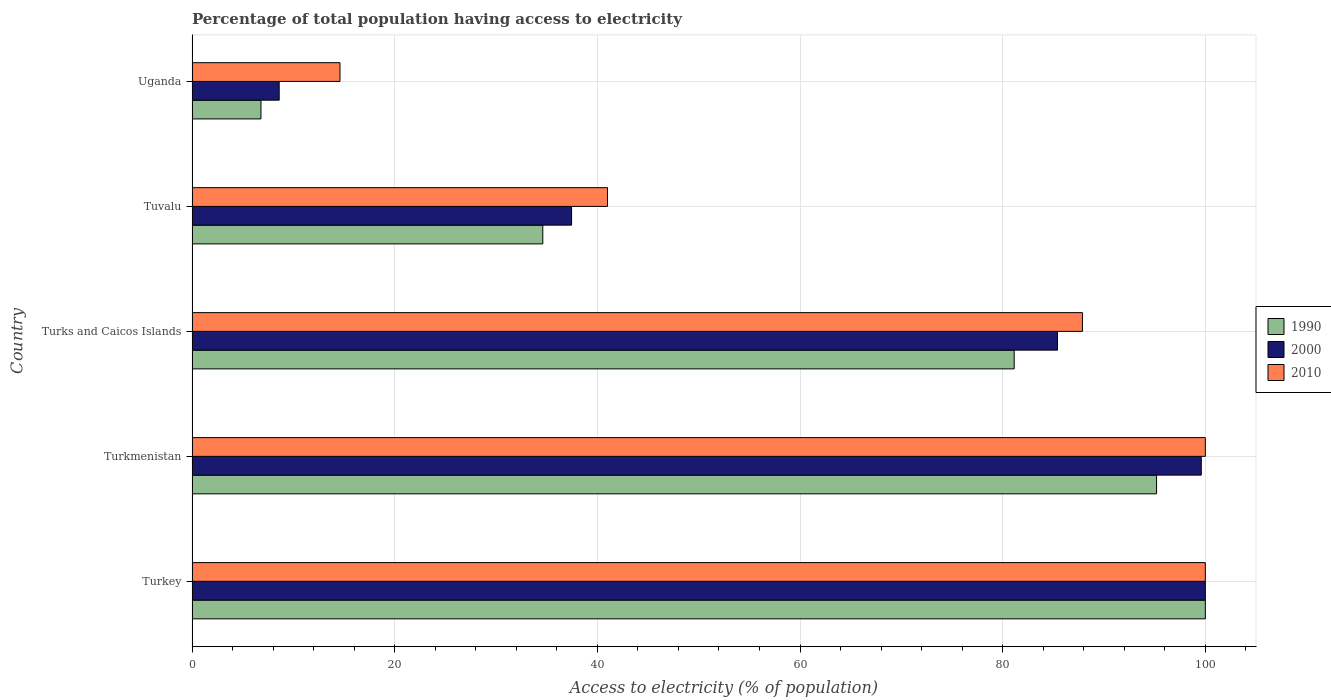How many groups of bars are there?
Give a very brief answer. 5. Are the number of bars per tick equal to the number of legend labels?
Your answer should be very brief. Yes. What is the label of the 3rd group of bars from the top?
Offer a very short reply. Turks and Caicos Islands. What is the percentage of population that have access to electricity in 2010 in Turkmenistan?
Provide a succinct answer. 100. Across all countries, what is the minimum percentage of population that have access to electricity in 2000?
Make the answer very short. 8.6. In which country was the percentage of population that have access to electricity in 1990 maximum?
Keep it short and to the point. Turkey. In which country was the percentage of population that have access to electricity in 2010 minimum?
Offer a terse response. Uganda. What is the total percentage of population that have access to electricity in 2000 in the graph?
Give a very brief answer. 331.07. What is the difference between the percentage of population that have access to electricity in 1990 in Turks and Caicos Islands and that in Tuvalu?
Ensure brevity in your answer.  46.52. What is the difference between the percentage of population that have access to electricity in 2010 in Uganda and the percentage of population that have access to electricity in 2000 in Tuvalu?
Provide a succinct answer. -22.86. What is the average percentage of population that have access to electricity in 2010 per country?
Provide a short and direct response. 68.69. What is the difference between the percentage of population that have access to electricity in 2010 and percentage of population that have access to electricity in 2000 in Uganda?
Your answer should be compact. 6. What is the ratio of the percentage of population that have access to electricity in 2000 in Turks and Caicos Islands to that in Uganda?
Your answer should be compact. 9.93. Is the percentage of population that have access to electricity in 1990 in Turkey less than that in Turks and Caicos Islands?
Provide a succinct answer. No. Is the difference between the percentage of population that have access to electricity in 2010 in Turks and Caicos Islands and Uganda greater than the difference between the percentage of population that have access to electricity in 2000 in Turks and Caicos Islands and Uganda?
Give a very brief answer. No. What is the difference between the highest and the second highest percentage of population that have access to electricity in 1990?
Ensure brevity in your answer.  4.81. What is the difference between the highest and the lowest percentage of population that have access to electricity in 2010?
Make the answer very short. 85.4. Is the sum of the percentage of population that have access to electricity in 2000 in Turkmenistan and Uganda greater than the maximum percentage of population that have access to electricity in 1990 across all countries?
Give a very brief answer. Yes. How many countries are there in the graph?
Make the answer very short. 5. What is the difference between two consecutive major ticks on the X-axis?
Offer a very short reply. 20. Are the values on the major ticks of X-axis written in scientific E-notation?
Give a very brief answer. No. Does the graph contain grids?
Your answer should be very brief. Yes. What is the title of the graph?
Keep it short and to the point. Percentage of total population having access to electricity. Does "2002" appear as one of the legend labels in the graph?
Provide a succinct answer. No. What is the label or title of the X-axis?
Offer a very short reply. Access to electricity (% of population). What is the label or title of the Y-axis?
Your answer should be very brief. Country. What is the Access to electricity (% of population) in 1990 in Turkmenistan?
Offer a very short reply. 95.19. What is the Access to electricity (% of population) of 2000 in Turkmenistan?
Your answer should be very brief. 99.6. What is the Access to electricity (% of population) of 2010 in Turkmenistan?
Your answer should be very brief. 100. What is the Access to electricity (% of population) of 1990 in Turks and Caicos Islands?
Your response must be concise. 81.14. What is the Access to electricity (% of population) of 2000 in Turks and Caicos Islands?
Make the answer very short. 85.41. What is the Access to electricity (% of population) of 2010 in Turks and Caicos Islands?
Your response must be concise. 87.87. What is the Access to electricity (% of population) of 1990 in Tuvalu?
Make the answer very short. 34.62. What is the Access to electricity (% of population) of 2000 in Tuvalu?
Provide a succinct answer. 37.46. What is the Access to electricity (% of population) of 1990 in Uganda?
Offer a very short reply. 6.8. What is the Access to electricity (% of population) of 2000 in Uganda?
Your response must be concise. 8.6. What is the Access to electricity (% of population) of 2010 in Uganda?
Offer a very short reply. 14.6. Across all countries, what is the maximum Access to electricity (% of population) of 1990?
Give a very brief answer. 100. Across all countries, what is the maximum Access to electricity (% of population) in 2000?
Your answer should be very brief. 100. Across all countries, what is the minimum Access to electricity (% of population) in 2010?
Provide a short and direct response. 14.6. What is the total Access to electricity (% of population) of 1990 in the graph?
Keep it short and to the point. 317.74. What is the total Access to electricity (% of population) in 2000 in the graph?
Ensure brevity in your answer.  331.07. What is the total Access to electricity (% of population) of 2010 in the graph?
Provide a succinct answer. 343.47. What is the difference between the Access to electricity (% of population) of 1990 in Turkey and that in Turkmenistan?
Ensure brevity in your answer.  4.81. What is the difference between the Access to electricity (% of population) in 2010 in Turkey and that in Turkmenistan?
Your answer should be compact. 0. What is the difference between the Access to electricity (% of population) in 1990 in Turkey and that in Turks and Caicos Islands?
Offer a very short reply. 18.86. What is the difference between the Access to electricity (% of population) of 2000 in Turkey and that in Turks and Caicos Islands?
Offer a very short reply. 14.59. What is the difference between the Access to electricity (% of population) of 2010 in Turkey and that in Turks and Caicos Islands?
Provide a short and direct response. 12.13. What is the difference between the Access to electricity (% of population) of 1990 in Turkey and that in Tuvalu?
Make the answer very short. 65.38. What is the difference between the Access to electricity (% of population) of 2000 in Turkey and that in Tuvalu?
Give a very brief answer. 62.54. What is the difference between the Access to electricity (% of population) in 2010 in Turkey and that in Tuvalu?
Provide a short and direct response. 59. What is the difference between the Access to electricity (% of population) of 1990 in Turkey and that in Uganda?
Offer a terse response. 93.2. What is the difference between the Access to electricity (% of population) in 2000 in Turkey and that in Uganda?
Give a very brief answer. 91.4. What is the difference between the Access to electricity (% of population) in 2010 in Turkey and that in Uganda?
Offer a terse response. 85.4. What is the difference between the Access to electricity (% of population) of 1990 in Turkmenistan and that in Turks and Caicos Islands?
Your answer should be compact. 14.05. What is the difference between the Access to electricity (% of population) of 2000 in Turkmenistan and that in Turks and Caicos Islands?
Ensure brevity in your answer.  14.19. What is the difference between the Access to electricity (% of population) in 2010 in Turkmenistan and that in Turks and Caicos Islands?
Make the answer very short. 12.13. What is the difference between the Access to electricity (% of population) of 1990 in Turkmenistan and that in Tuvalu?
Offer a terse response. 60.57. What is the difference between the Access to electricity (% of population) of 2000 in Turkmenistan and that in Tuvalu?
Your response must be concise. 62.14. What is the difference between the Access to electricity (% of population) of 1990 in Turkmenistan and that in Uganda?
Your answer should be very brief. 88.39. What is the difference between the Access to electricity (% of population) of 2000 in Turkmenistan and that in Uganda?
Your answer should be very brief. 91. What is the difference between the Access to electricity (% of population) of 2010 in Turkmenistan and that in Uganda?
Give a very brief answer. 85.4. What is the difference between the Access to electricity (% of population) of 1990 in Turks and Caicos Islands and that in Tuvalu?
Make the answer very short. 46.52. What is the difference between the Access to electricity (% of population) of 2000 in Turks and Caicos Islands and that in Tuvalu?
Make the answer very short. 47.96. What is the difference between the Access to electricity (% of population) of 2010 in Turks and Caicos Islands and that in Tuvalu?
Keep it short and to the point. 46.87. What is the difference between the Access to electricity (% of population) of 1990 in Turks and Caicos Islands and that in Uganda?
Keep it short and to the point. 74.34. What is the difference between the Access to electricity (% of population) in 2000 in Turks and Caicos Islands and that in Uganda?
Your answer should be very brief. 76.81. What is the difference between the Access to electricity (% of population) in 2010 in Turks and Caicos Islands and that in Uganda?
Provide a short and direct response. 73.27. What is the difference between the Access to electricity (% of population) in 1990 in Tuvalu and that in Uganda?
Your answer should be very brief. 27.82. What is the difference between the Access to electricity (% of population) of 2000 in Tuvalu and that in Uganda?
Your answer should be very brief. 28.86. What is the difference between the Access to electricity (% of population) of 2010 in Tuvalu and that in Uganda?
Provide a succinct answer. 26.4. What is the difference between the Access to electricity (% of population) in 1990 in Turkey and the Access to electricity (% of population) in 2010 in Turkmenistan?
Offer a terse response. 0. What is the difference between the Access to electricity (% of population) in 2000 in Turkey and the Access to electricity (% of population) in 2010 in Turkmenistan?
Offer a terse response. 0. What is the difference between the Access to electricity (% of population) in 1990 in Turkey and the Access to electricity (% of population) in 2000 in Turks and Caicos Islands?
Offer a terse response. 14.59. What is the difference between the Access to electricity (% of population) in 1990 in Turkey and the Access to electricity (% of population) in 2010 in Turks and Caicos Islands?
Provide a short and direct response. 12.13. What is the difference between the Access to electricity (% of population) of 2000 in Turkey and the Access to electricity (% of population) of 2010 in Turks and Caicos Islands?
Your response must be concise. 12.13. What is the difference between the Access to electricity (% of population) in 1990 in Turkey and the Access to electricity (% of population) in 2000 in Tuvalu?
Your response must be concise. 62.54. What is the difference between the Access to electricity (% of population) of 1990 in Turkey and the Access to electricity (% of population) of 2010 in Tuvalu?
Offer a very short reply. 59. What is the difference between the Access to electricity (% of population) in 2000 in Turkey and the Access to electricity (% of population) in 2010 in Tuvalu?
Offer a terse response. 59. What is the difference between the Access to electricity (% of population) in 1990 in Turkey and the Access to electricity (% of population) in 2000 in Uganda?
Your response must be concise. 91.4. What is the difference between the Access to electricity (% of population) of 1990 in Turkey and the Access to electricity (% of population) of 2010 in Uganda?
Keep it short and to the point. 85.4. What is the difference between the Access to electricity (% of population) in 2000 in Turkey and the Access to electricity (% of population) in 2010 in Uganda?
Your answer should be very brief. 85.4. What is the difference between the Access to electricity (% of population) in 1990 in Turkmenistan and the Access to electricity (% of population) in 2000 in Turks and Caicos Islands?
Keep it short and to the point. 9.78. What is the difference between the Access to electricity (% of population) in 1990 in Turkmenistan and the Access to electricity (% of population) in 2010 in Turks and Caicos Islands?
Offer a very short reply. 7.31. What is the difference between the Access to electricity (% of population) of 2000 in Turkmenistan and the Access to electricity (% of population) of 2010 in Turks and Caicos Islands?
Offer a terse response. 11.73. What is the difference between the Access to electricity (% of population) in 1990 in Turkmenistan and the Access to electricity (% of population) in 2000 in Tuvalu?
Your answer should be compact. 57.73. What is the difference between the Access to electricity (% of population) in 1990 in Turkmenistan and the Access to electricity (% of population) in 2010 in Tuvalu?
Your answer should be compact. 54.19. What is the difference between the Access to electricity (% of population) in 2000 in Turkmenistan and the Access to electricity (% of population) in 2010 in Tuvalu?
Provide a short and direct response. 58.6. What is the difference between the Access to electricity (% of population) of 1990 in Turkmenistan and the Access to electricity (% of population) of 2000 in Uganda?
Your response must be concise. 86.59. What is the difference between the Access to electricity (% of population) in 1990 in Turkmenistan and the Access to electricity (% of population) in 2010 in Uganda?
Offer a terse response. 80.59. What is the difference between the Access to electricity (% of population) in 2000 in Turkmenistan and the Access to electricity (% of population) in 2010 in Uganda?
Your answer should be compact. 85. What is the difference between the Access to electricity (% of population) in 1990 in Turks and Caicos Islands and the Access to electricity (% of population) in 2000 in Tuvalu?
Provide a short and direct response. 43.68. What is the difference between the Access to electricity (% of population) in 1990 in Turks and Caicos Islands and the Access to electricity (% of population) in 2010 in Tuvalu?
Make the answer very short. 40.14. What is the difference between the Access to electricity (% of population) of 2000 in Turks and Caicos Islands and the Access to electricity (% of population) of 2010 in Tuvalu?
Keep it short and to the point. 44.41. What is the difference between the Access to electricity (% of population) of 1990 in Turks and Caicos Islands and the Access to electricity (% of population) of 2000 in Uganda?
Provide a succinct answer. 72.54. What is the difference between the Access to electricity (% of population) of 1990 in Turks and Caicos Islands and the Access to electricity (% of population) of 2010 in Uganda?
Your answer should be compact. 66.54. What is the difference between the Access to electricity (% of population) of 2000 in Turks and Caicos Islands and the Access to electricity (% of population) of 2010 in Uganda?
Offer a terse response. 70.81. What is the difference between the Access to electricity (% of population) of 1990 in Tuvalu and the Access to electricity (% of population) of 2000 in Uganda?
Give a very brief answer. 26.02. What is the difference between the Access to electricity (% of population) in 1990 in Tuvalu and the Access to electricity (% of population) in 2010 in Uganda?
Your response must be concise. 20.02. What is the difference between the Access to electricity (% of population) of 2000 in Tuvalu and the Access to electricity (% of population) of 2010 in Uganda?
Offer a terse response. 22.86. What is the average Access to electricity (% of population) in 1990 per country?
Provide a succinct answer. 63.55. What is the average Access to electricity (% of population) of 2000 per country?
Make the answer very short. 66.21. What is the average Access to electricity (% of population) of 2010 per country?
Your response must be concise. 68.69. What is the difference between the Access to electricity (% of population) of 2000 and Access to electricity (% of population) of 2010 in Turkey?
Make the answer very short. 0. What is the difference between the Access to electricity (% of population) of 1990 and Access to electricity (% of population) of 2000 in Turkmenistan?
Make the answer very short. -4.41. What is the difference between the Access to electricity (% of population) of 1990 and Access to electricity (% of population) of 2010 in Turkmenistan?
Make the answer very short. -4.81. What is the difference between the Access to electricity (% of population) in 2000 and Access to electricity (% of population) in 2010 in Turkmenistan?
Keep it short and to the point. -0.4. What is the difference between the Access to electricity (% of population) of 1990 and Access to electricity (% of population) of 2000 in Turks and Caicos Islands?
Offer a very short reply. -4.28. What is the difference between the Access to electricity (% of population) in 1990 and Access to electricity (% of population) in 2010 in Turks and Caicos Islands?
Offer a terse response. -6.74. What is the difference between the Access to electricity (% of population) of 2000 and Access to electricity (% of population) of 2010 in Turks and Caicos Islands?
Ensure brevity in your answer.  -2.46. What is the difference between the Access to electricity (% of population) of 1990 and Access to electricity (% of population) of 2000 in Tuvalu?
Ensure brevity in your answer.  -2.84. What is the difference between the Access to electricity (% of population) of 1990 and Access to electricity (% of population) of 2010 in Tuvalu?
Offer a very short reply. -6.38. What is the difference between the Access to electricity (% of population) of 2000 and Access to electricity (% of population) of 2010 in Tuvalu?
Offer a very short reply. -3.54. What is the difference between the Access to electricity (% of population) in 1990 and Access to electricity (% of population) in 2000 in Uganda?
Your answer should be compact. -1.8. What is the difference between the Access to electricity (% of population) of 1990 and Access to electricity (% of population) of 2010 in Uganda?
Your answer should be compact. -7.8. What is the ratio of the Access to electricity (% of population) in 1990 in Turkey to that in Turkmenistan?
Keep it short and to the point. 1.05. What is the ratio of the Access to electricity (% of population) of 2000 in Turkey to that in Turkmenistan?
Give a very brief answer. 1. What is the ratio of the Access to electricity (% of population) of 2010 in Turkey to that in Turkmenistan?
Your answer should be very brief. 1. What is the ratio of the Access to electricity (% of population) of 1990 in Turkey to that in Turks and Caicos Islands?
Ensure brevity in your answer.  1.23. What is the ratio of the Access to electricity (% of population) in 2000 in Turkey to that in Turks and Caicos Islands?
Your answer should be very brief. 1.17. What is the ratio of the Access to electricity (% of population) of 2010 in Turkey to that in Turks and Caicos Islands?
Provide a short and direct response. 1.14. What is the ratio of the Access to electricity (% of population) of 1990 in Turkey to that in Tuvalu?
Provide a short and direct response. 2.89. What is the ratio of the Access to electricity (% of population) of 2000 in Turkey to that in Tuvalu?
Your answer should be compact. 2.67. What is the ratio of the Access to electricity (% of population) of 2010 in Turkey to that in Tuvalu?
Offer a terse response. 2.44. What is the ratio of the Access to electricity (% of population) in 1990 in Turkey to that in Uganda?
Your answer should be very brief. 14.71. What is the ratio of the Access to electricity (% of population) in 2000 in Turkey to that in Uganda?
Provide a succinct answer. 11.63. What is the ratio of the Access to electricity (% of population) of 2010 in Turkey to that in Uganda?
Give a very brief answer. 6.85. What is the ratio of the Access to electricity (% of population) in 1990 in Turkmenistan to that in Turks and Caicos Islands?
Your answer should be compact. 1.17. What is the ratio of the Access to electricity (% of population) in 2000 in Turkmenistan to that in Turks and Caicos Islands?
Provide a succinct answer. 1.17. What is the ratio of the Access to electricity (% of population) in 2010 in Turkmenistan to that in Turks and Caicos Islands?
Ensure brevity in your answer.  1.14. What is the ratio of the Access to electricity (% of population) of 1990 in Turkmenistan to that in Tuvalu?
Provide a succinct answer. 2.75. What is the ratio of the Access to electricity (% of population) in 2000 in Turkmenistan to that in Tuvalu?
Your answer should be compact. 2.66. What is the ratio of the Access to electricity (% of population) of 2010 in Turkmenistan to that in Tuvalu?
Make the answer very short. 2.44. What is the ratio of the Access to electricity (% of population) of 1990 in Turkmenistan to that in Uganda?
Provide a succinct answer. 14. What is the ratio of the Access to electricity (% of population) of 2000 in Turkmenistan to that in Uganda?
Your response must be concise. 11.58. What is the ratio of the Access to electricity (% of population) in 2010 in Turkmenistan to that in Uganda?
Ensure brevity in your answer.  6.85. What is the ratio of the Access to electricity (% of population) of 1990 in Turks and Caicos Islands to that in Tuvalu?
Make the answer very short. 2.34. What is the ratio of the Access to electricity (% of population) of 2000 in Turks and Caicos Islands to that in Tuvalu?
Provide a succinct answer. 2.28. What is the ratio of the Access to electricity (% of population) of 2010 in Turks and Caicos Islands to that in Tuvalu?
Keep it short and to the point. 2.14. What is the ratio of the Access to electricity (% of population) in 1990 in Turks and Caicos Islands to that in Uganda?
Offer a very short reply. 11.93. What is the ratio of the Access to electricity (% of population) of 2000 in Turks and Caicos Islands to that in Uganda?
Your answer should be compact. 9.93. What is the ratio of the Access to electricity (% of population) in 2010 in Turks and Caicos Islands to that in Uganda?
Offer a terse response. 6.02. What is the ratio of the Access to electricity (% of population) in 1990 in Tuvalu to that in Uganda?
Provide a short and direct response. 5.09. What is the ratio of the Access to electricity (% of population) in 2000 in Tuvalu to that in Uganda?
Keep it short and to the point. 4.36. What is the ratio of the Access to electricity (% of population) of 2010 in Tuvalu to that in Uganda?
Your response must be concise. 2.81. What is the difference between the highest and the second highest Access to electricity (% of population) in 1990?
Provide a short and direct response. 4.81. What is the difference between the highest and the lowest Access to electricity (% of population) of 1990?
Offer a very short reply. 93.2. What is the difference between the highest and the lowest Access to electricity (% of population) of 2000?
Provide a short and direct response. 91.4. What is the difference between the highest and the lowest Access to electricity (% of population) of 2010?
Offer a terse response. 85.4. 